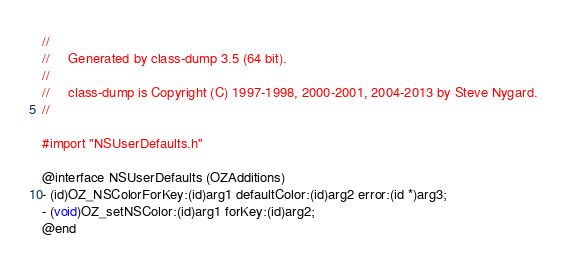<code> <loc_0><loc_0><loc_500><loc_500><_C_>//
//     Generated by class-dump 3.5 (64 bit).
//
//     class-dump is Copyright (C) 1997-1998, 2000-2001, 2004-2013 by Steve Nygard.
//

#import "NSUserDefaults.h"

@interface NSUserDefaults (OZAdditions)
- (id)OZ_NSColorForKey:(id)arg1 defaultColor:(id)arg2 error:(id *)arg3;
- (void)OZ_setNSColor:(id)arg1 forKey:(id)arg2;
@end

</code> 